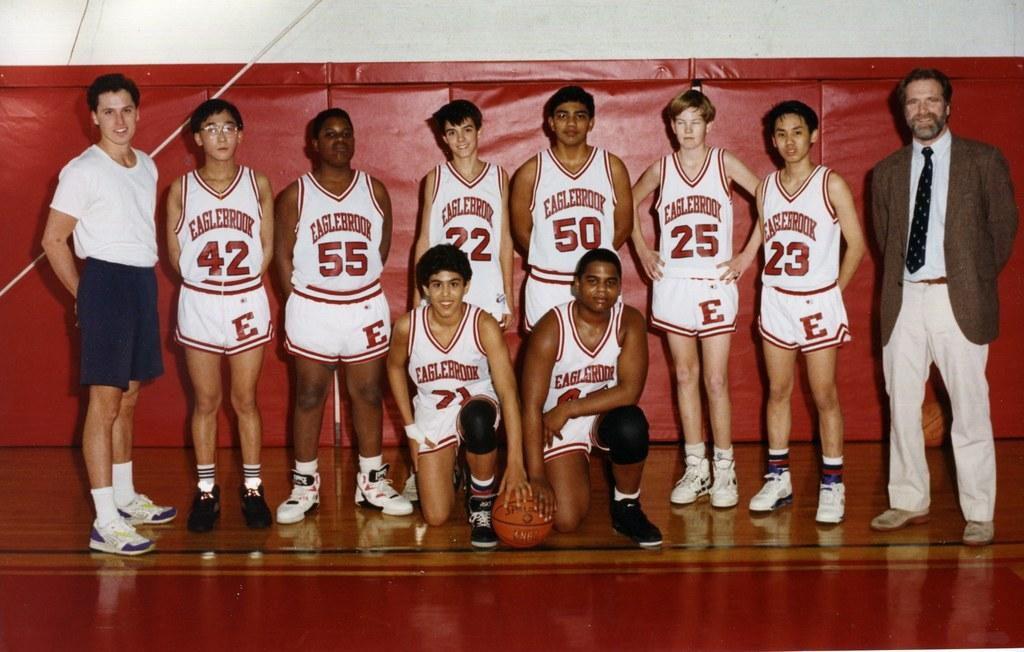Provide a one-sentence caption for the provided image. Basketball players from Eaglebrook are posing for a picture with their coaches. 